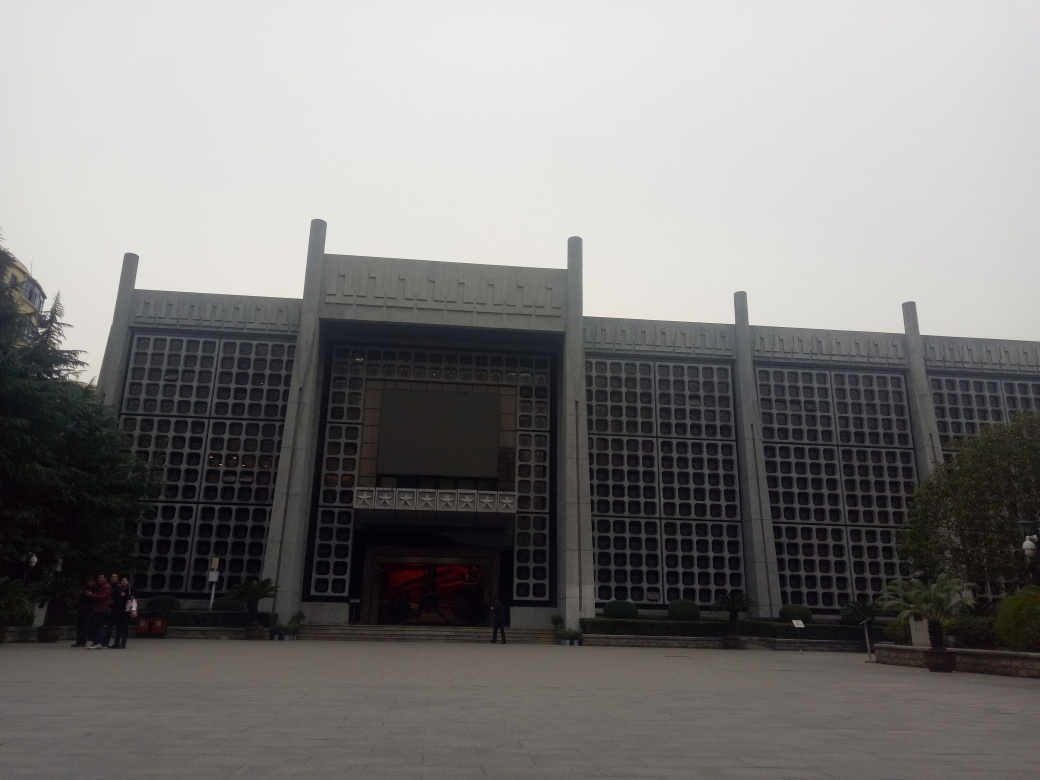What is the surface texture of the building like in this image? A. Smooth B. Rough C. Dense Answer with the option's letter from the given choices directly. The building's exterior walls feature a patterned relief that could give the impression of a dense texture at first glance. However, upon closer inspection, the uniformity and precision of the patterns suggest the surface is more smooth than rough. Although 'C. Dense' was provided as an answer, a more accurate description would be 'A. Smooth,' given the methodical and deliberate design of the facade. 